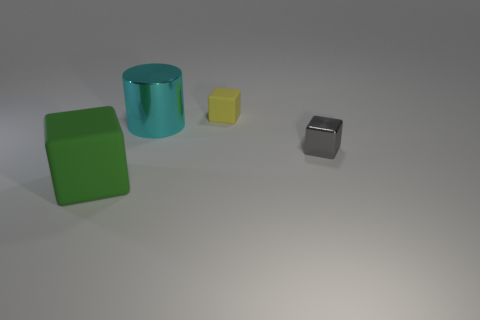Add 3 big cyan metallic things. How many objects exist? 7 Subtract all cylinders. How many objects are left? 3 Subtract 0 yellow balls. How many objects are left? 4 Subtract all brown things. Subtract all yellow matte things. How many objects are left? 3 Add 3 gray metallic blocks. How many gray metallic blocks are left? 4 Add 3 tiny cyan metal objects. How many tiny cyan metal objects exist? 3 